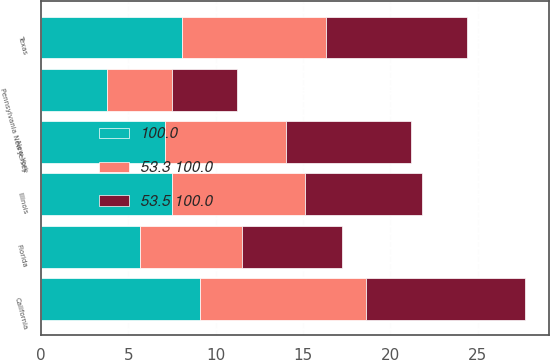Convert chart to OTSL. <chart><loc_0><loc_0><loc_500><loc_500><stacked_bar_chart><ecel><fcel>California<fcel>Texas<fcel>Illinois<fcel>New York<fcel>Florida<fcel>Pennsylvania New Jersey<nl><fcel>53.3 100.0<fcel>9.5<fcel>8.2<fcel>7.6<fcel>6.9<fcel>5.8<fcel>3.7<nl><fcel>100.0<fcel>9.1<fcel>8.1<fcel>7.5<fcel>7.1<fcel>5.7<fcel>3.8<nl><fcel>53.5 100.0<fcel>9.1<fcel>8.1<fcel>6.7<fcel>7.2<fcel>5.7<fcel>3.7<nl></chart> 